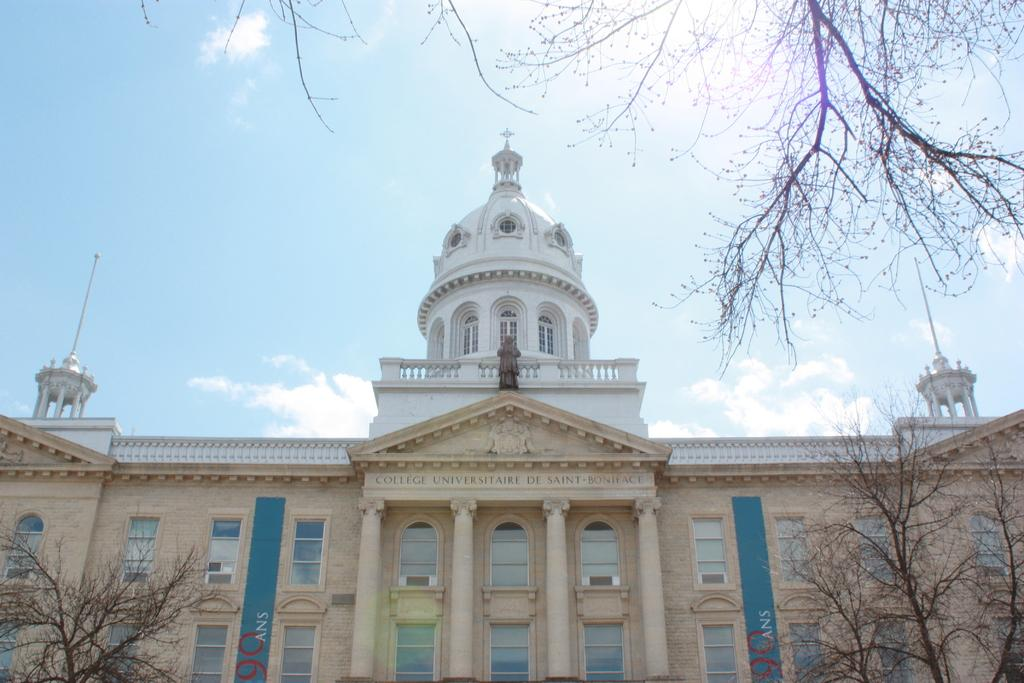What type of vegetation can be seen in the image? There are trees in the image. What structure is visible in the background of the image? There is a building in the background of the image. What is visible in the sky in the image? The sky is clear and visible in the background of the image. What type of plot is being prepared for planting in the image? There is no plot visible in the image; it only features trees. What type of food is being cooked in the image? There is no cooking activity depicted in the image. 